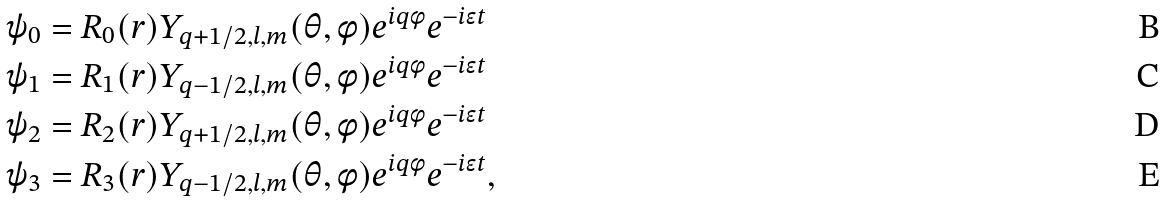<formula> <loc_0><loc_0><loc_500><loc_500>\psi _ { 0 } & = R _ { 0 } ( r ) Y _ { q + 1 / 2 , l , m } ( \theta , \phi ) e ^ { i q \phi } e ^ { - i \epsilon t } \\ \psi _ { 1 } & = R _ { 1 } ( r ) Y _ { q - 1 / 2 , l , m } ( \theta , \phi ) e ^ { i q \phi } e ^ { - i \epsilon t } \\ \psi _ { 2 } & = R _ { 2 } ( r ) Y _ { q + 1 / 2 , l , m } ( \theta , \phi ) e ^ { i q \phi } e ^ { - i \epsilon t } \\ \psi _ { 3 } & = R _ { 3 } ( r ) Y _ { q - 1 / 2 , l , m } ( \theta , \phi ) e ^ { i q \phi } e ^ { - i \epsilon t } ,</formula> 